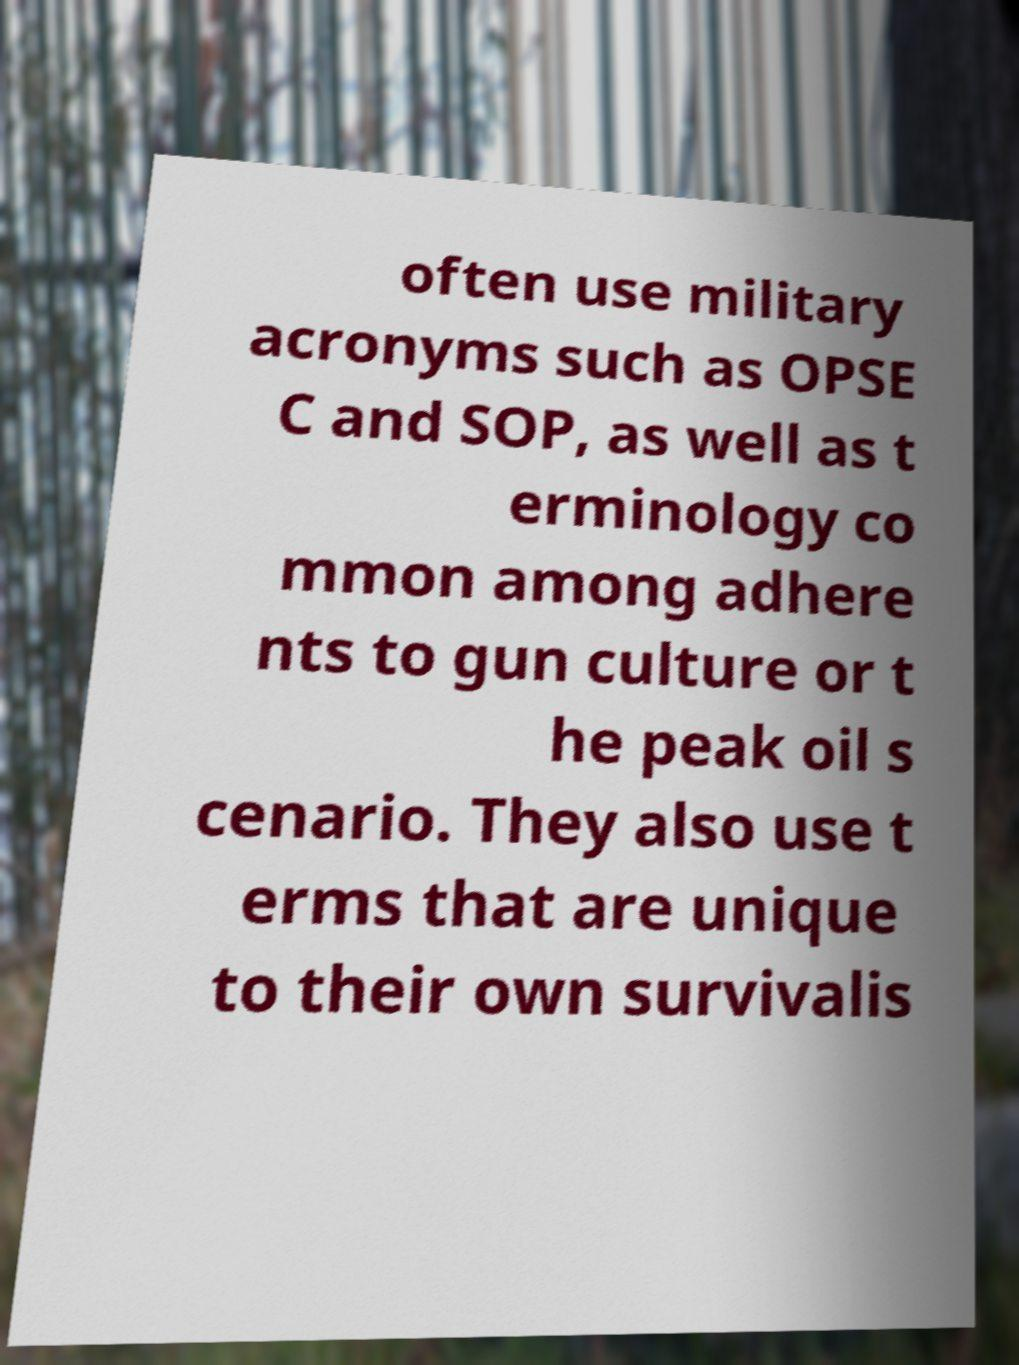Could you assist in decoding the text presented in this image and type it out clearly? often use military acronyms such as OPSE C and SOP, as well as t erminology co mmon among adhere nts to gun culture or t he peak oil s cenario. They also use t erms that are unique to their own survivalis 